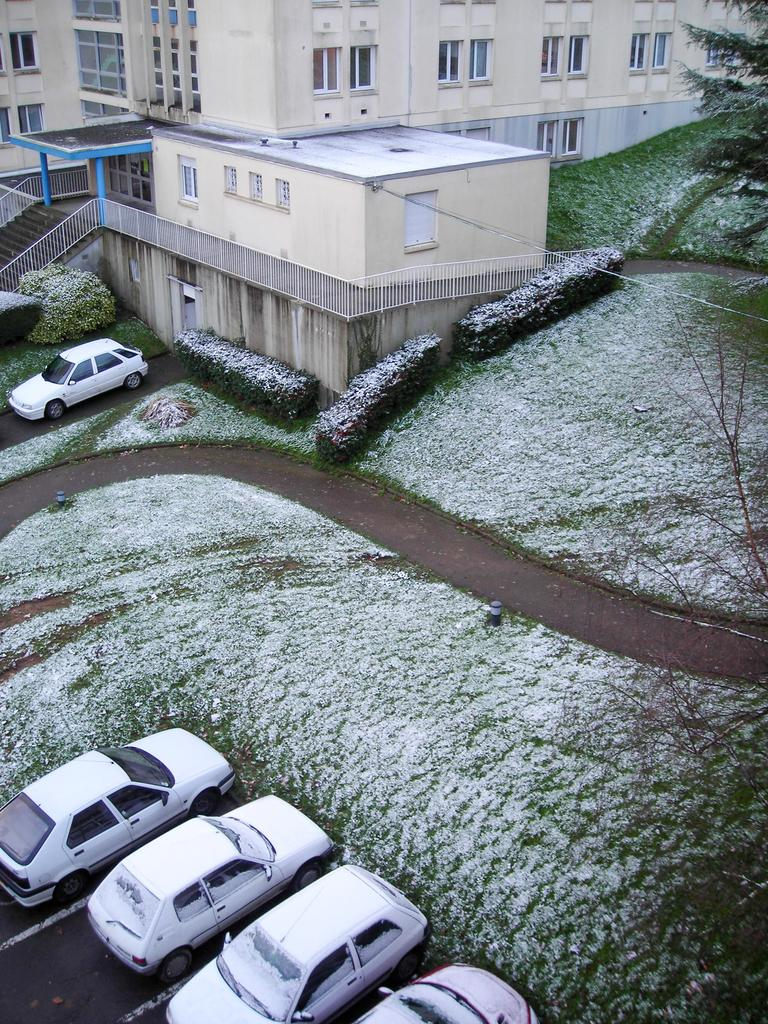What type of vehicles are in the bottom left hand corner of the image? There are cars in the bottom left hand corner of the image. What structure can be seen in the image? There is a building in the image. What word is written on the side of the building in the image? There is no word written on the side of the building in the image. What type of iron is used to construct the building in the image? The image does not provide information about the materials used to construct the building. 